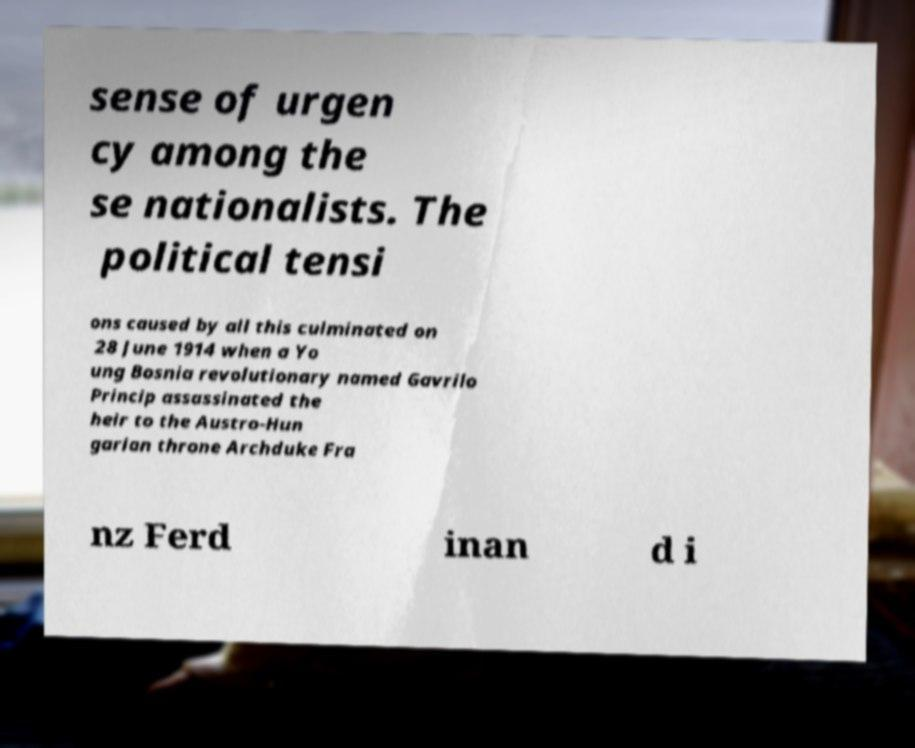Please read and relay the text visible in this image. What does it say? sense of urgen cy among the se nationalists. The political tensi ons caused by all this culminated on 28 June 1914 when a Yo ung Bosnia revolutionary named Gavrilo Princip assassinated the heir to the Austro-Hun garian throne Archduke Fra nz Ferd inan d i 